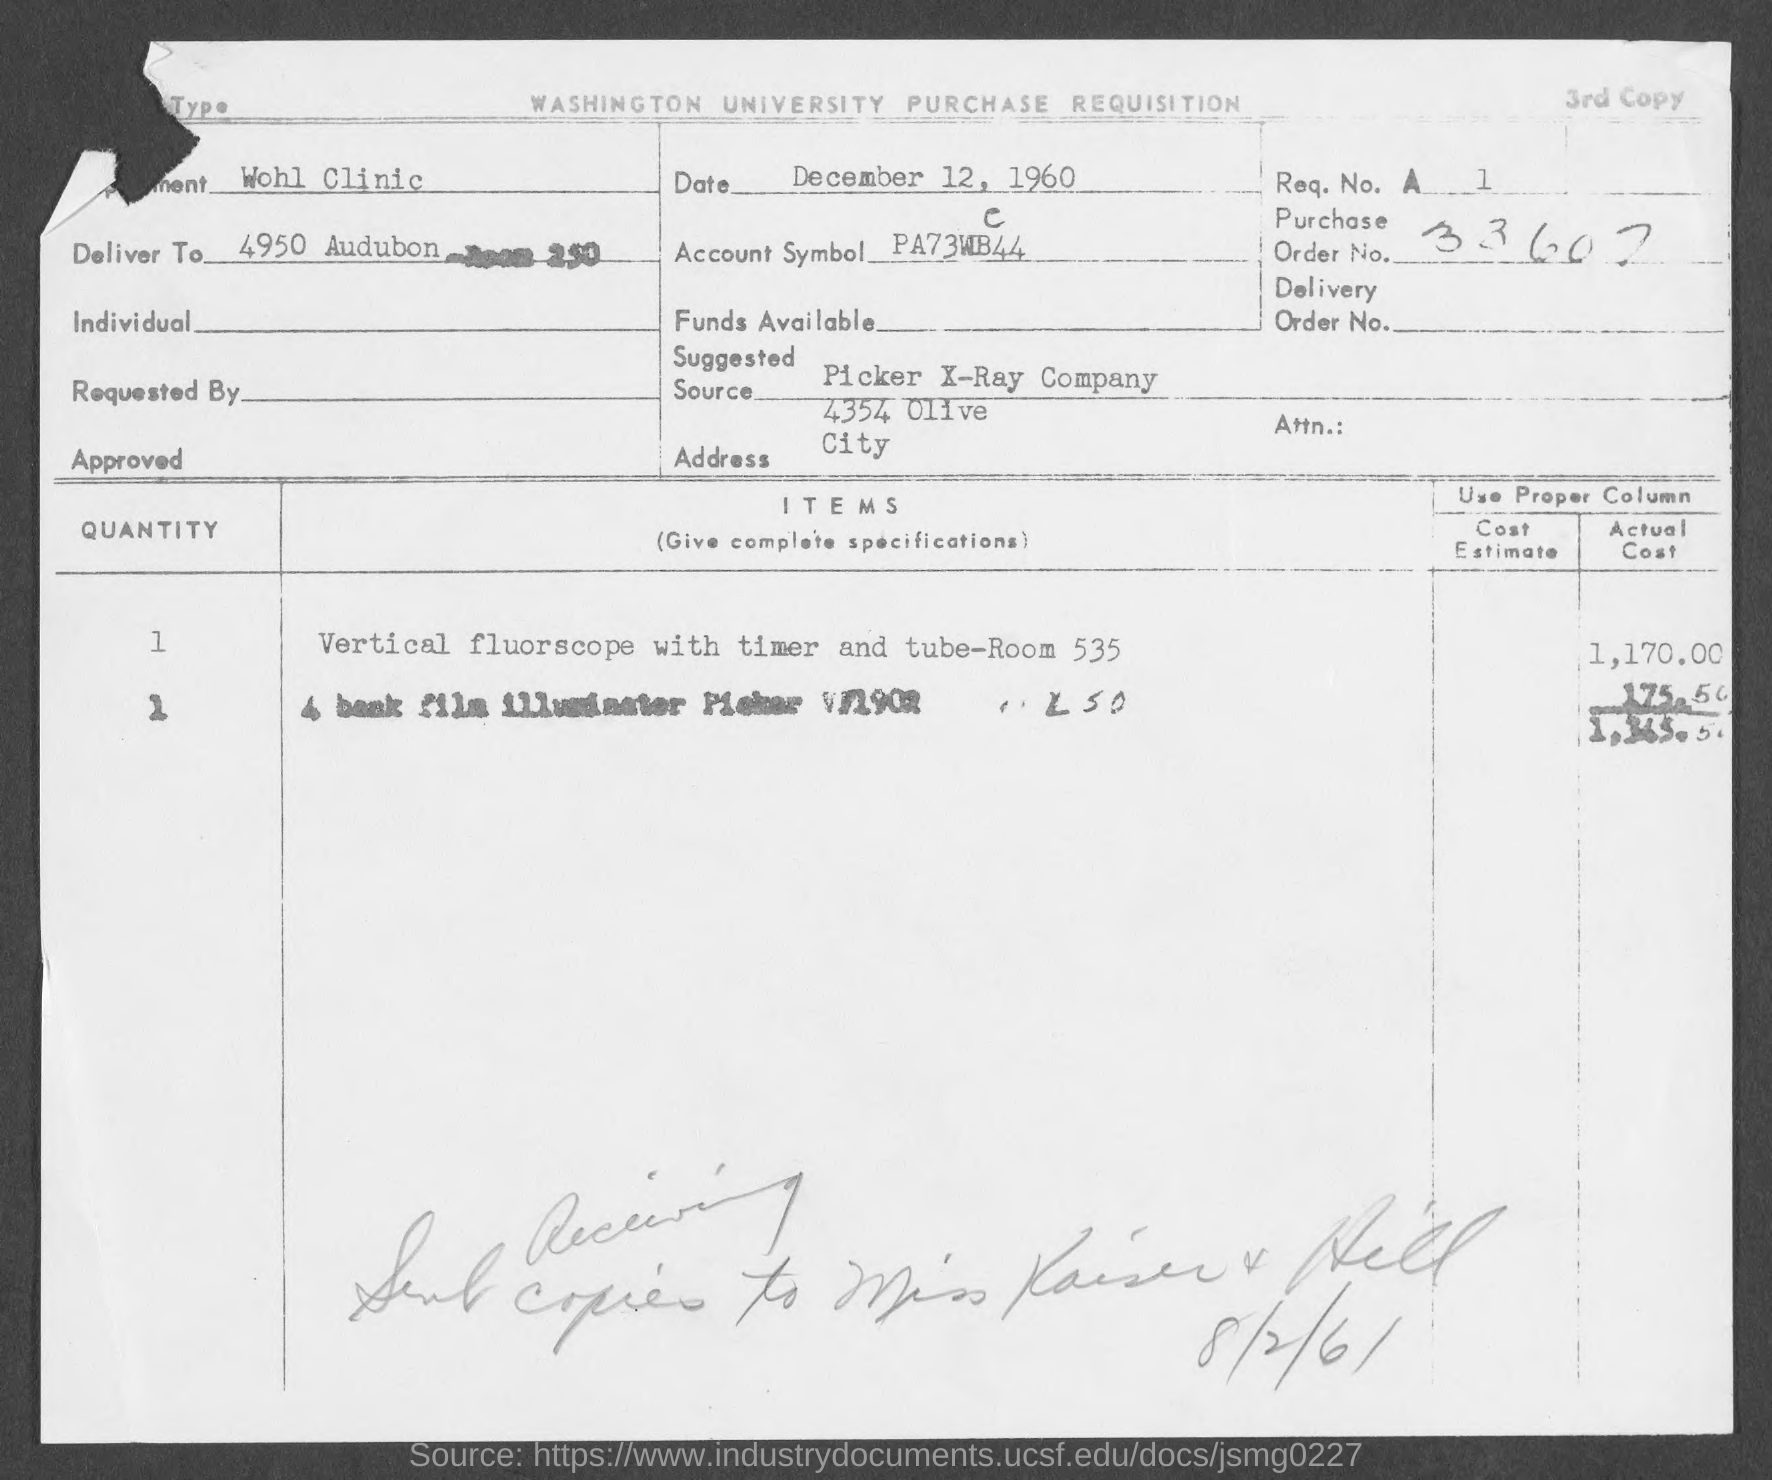Draw attention to some important aspects in this diagram. The purchase order number is 33607. The actual cost is 1,365.50. Picker X-Ray Company is the suggested source for obtaining the specified product. On December 12, 1960, the date is known. The department is the Wells Clinic. 